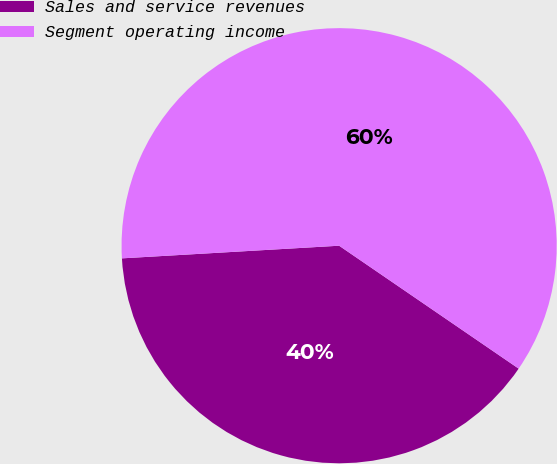Convert chart to OTSL. <chart><loc_0><loc_0><loc_500><loc_500><pie_chart><fcel>Sales and service revenues<fcel>Segment operating income<nl><fcel>39.52%<fcel>60.48%<nl></chart> 